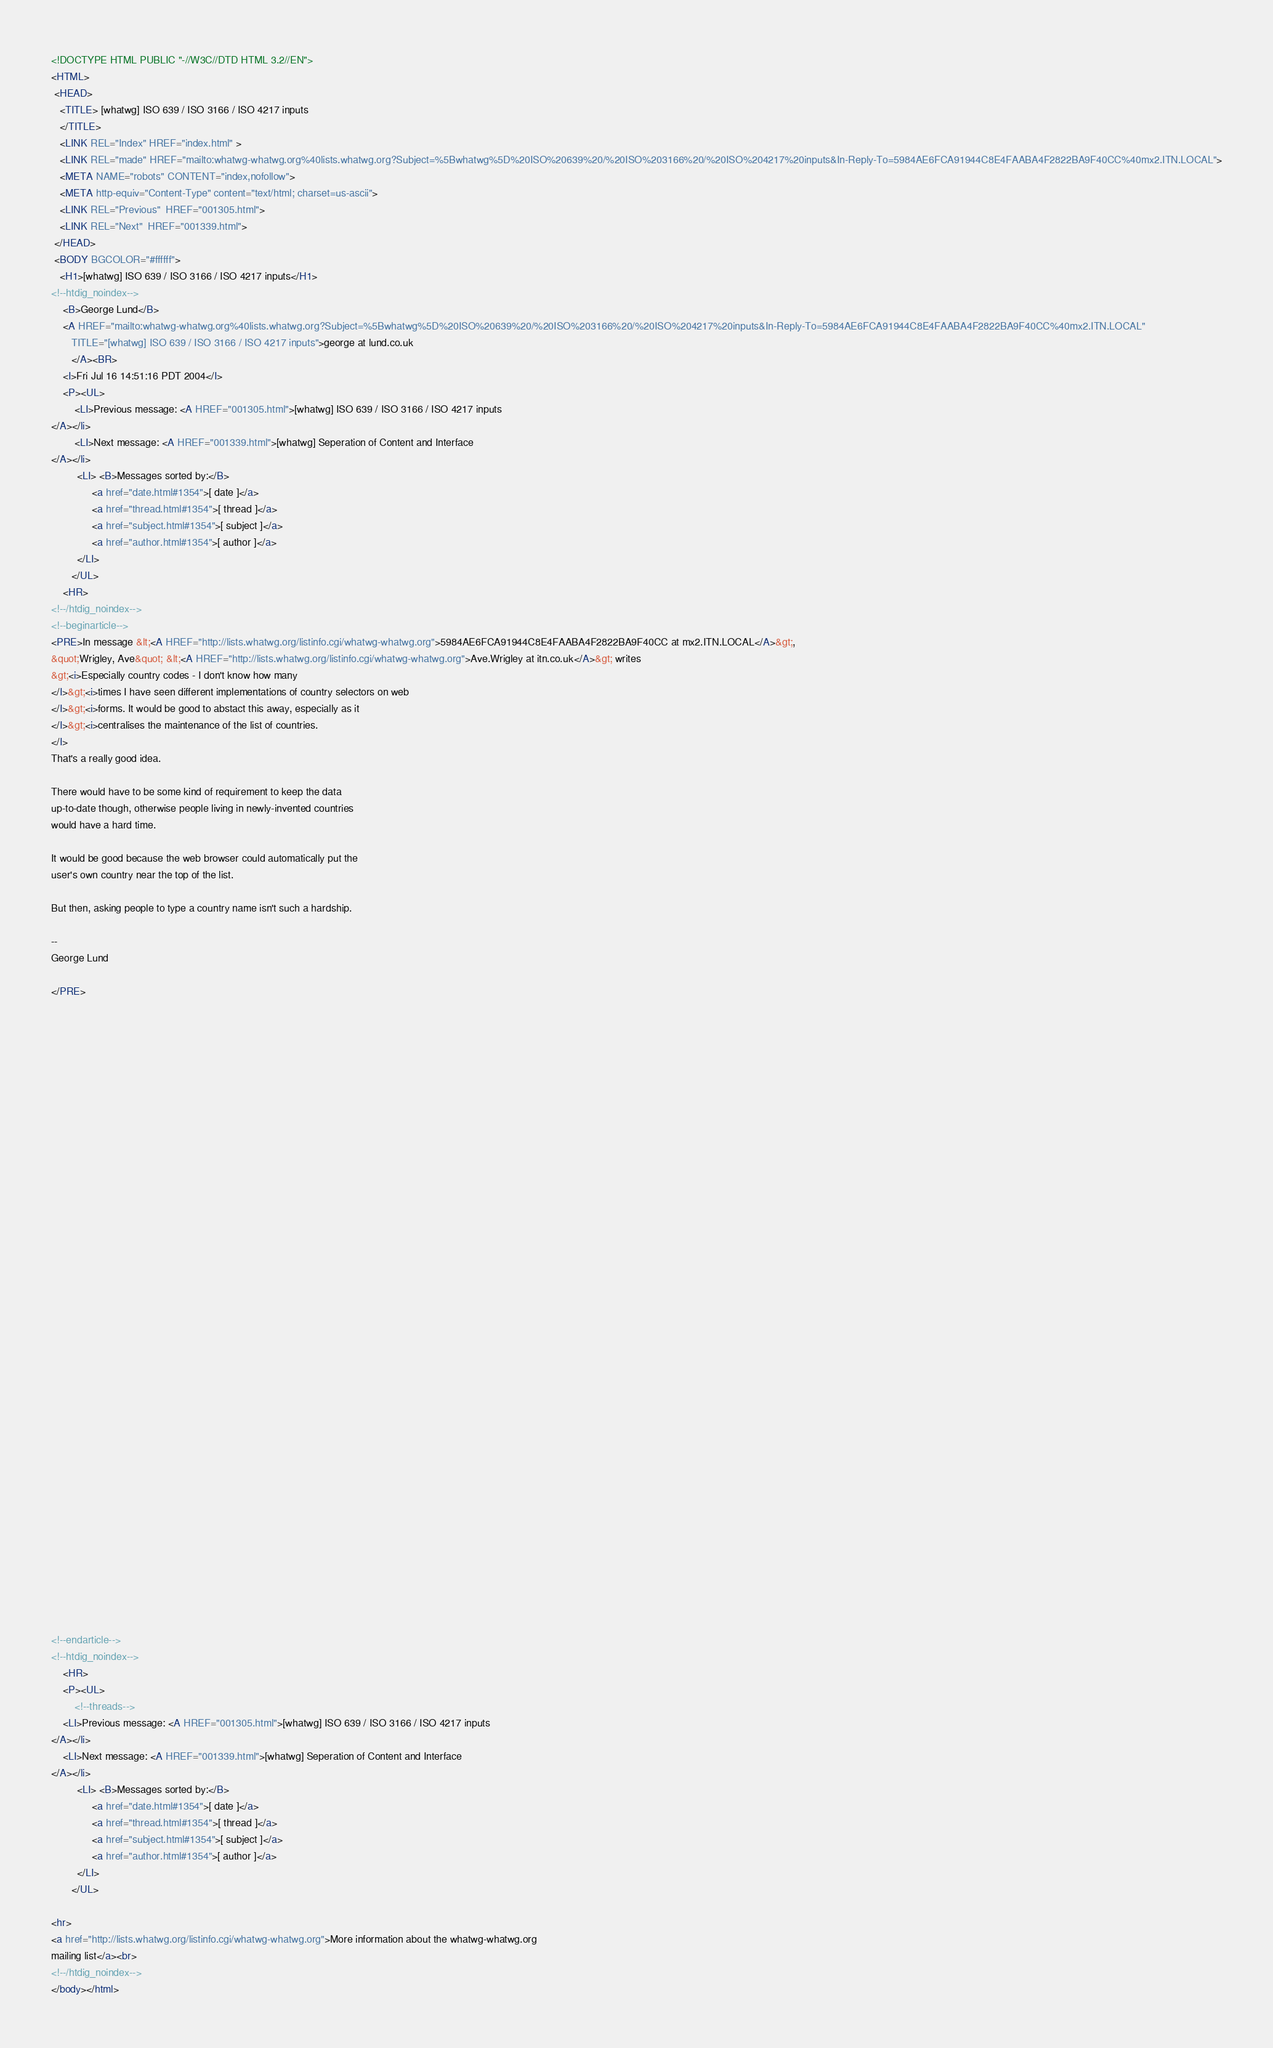Convert code to text. <code><loc_0><loc_0><loc_500><loc_500><_HTML_><!DOCTYPE HTML PUBLIC "-//W3C//DTD HTML 3.2//EN">
<HTML>
 <HEAD>
   <TITLE> [whatwg] ISO 639 / ISO 3166 / ISO 4217 inputs
   </TITLE>
   <LINK REL="Index" HREF="index.html" >
   <LINK REL="made" HREF="mailto:whatwg-whatwg.org%40lists.whatwg.org?Subject=%5Bwhatwg%5D%20ISO%20639%20/%20ISO%203166%20/%20ISO%204217%20inputs&In-Reply-To=5984AE6FCA91944C8E4FAABA4F2822BA9F40CC%40mx2.ITN.LOCAL">
   <META NAME="robots" CONTENT="index,nofollow">
   <META http-equiv="Content-Type" content="text/html; charset=us-ascii">
   <LINK REL="Previous"  HREF="001305.html">
   <LINK REL="Next"  HREF="001339.html">
 </HEAD>
 <BODY BGCOLOR="#ffffff">
   <H1>[whatwg] ISO 639 / ISO 3166 / ISO 4217 inputs</H1>
<!--htdig_noindex-->
    <B>George Lund</B> 
    <A HREF="mailto:whatwg-whatwg.org%40lists.whatwg.org?Subject=%5Bwhatwg%5D%20ISO%20639%20/%20ISO%203166%20/%20ISO%204217%20inputs&In-Reply-To=5984AE6FCA91944C8E4FAABA4F2822BA9F40CC%40mx2.ITN.LOCAL"
       TITLE="[whatwg] ISO 639 / ISO 3166 / ISO 4217 inputs">george at lund.co.uk
       </A><BR>
    <I>Fri Jul 16 14:51:16 PDT 2004</I>
    <P><UL>
        <LI>Previous message: <A HREF="001305.html">[whatwg] ISO 639 / ISO 3166 / ISO 4217 inputs
</A></li>
        <LI>Next message: <A HREF="001339.html">[whatwg] Seperation of Content and Interface
</A></li>
         <LI> <B>Messages sorted by:</B> 
              <a href="date.html#1354">[ date ]</a>
              <a href="thread.html#1354">[ thread ]</a>
              <a href="subject.html#1354">[ subject ]</a>
              <a href="author.html#1354">[ author ]</a>
         </LI>
       </UL>
    <HR>  
<!--/htdig_noindex-->
<!--beginarticle-->
<PRE>In message &lt;<A HREF="http://lists.whatwg.org/listinfo.cgi/whatwg-whatwg.org">5984AE6FCA91944C8E4FAABA4F2822BA9F40CC at mx2.ITN.LOCAL</A>&gt;, 
&quot;Wrigley, Ave&quot; &lt;<A HREF="http://lists.whatwg.org/listinfo.cgi/whatwg-whatwg.org">Ave.Wrigley at itn.co.uk</A>&gt; writes
&gt;<i>Especially country codes - I don't know how many
</I>&gt;<i>times I have seen different implementations of country selectors on web
</I>&gt;<i>forms. It would be good to abstact this away, especially as it
</I>&gt;<i>centralises the maintenance of the list of countries.
</I>
That's a really good idea.

There would have to be some kind of requirement to keep the data 
up-to-date though, otherwise people living in newly-invented countries 
would have a hard time.

It would be good because the web browser could automatically put the 
user's own country near the top of the list.

But then, asking people to type a country name isn't such a hardship.

-- 
George Lund

</PRE>






































<!--endarticle-->
<!--htdig_noindex-->
    <HR>
    <P><UL>
        <!--threads-->
	<LI>Previous message: <A HREF="001305.html">[whatwg] ISO 639 / ISO 3166 / ISO 4217 inputs
</A></li>
	<LI>Next message: <A HREF="001339.html">[whatwg] Seperation of Content and Interface
</A></li>
         <LI> <B>Messages sorted by:</B> 
              <a href="date.html#1354">[ date ]</a>
              <a href="thread.html#1354">[ thread ]</a>
              <a href="subject.html#1354">[ subject ]</a>
              <a href="author.html#1354">[ author ]</a>
         </LI>
       </UL>

<hr>
<a href="http://lists.whatwg.org/listinfo.cgi/whatwg-whatwg.org">More information about the whatwg-whatwg.org
mailing list</a><br>
<!--/htdig_noindex-->
</body></html>
</code> 